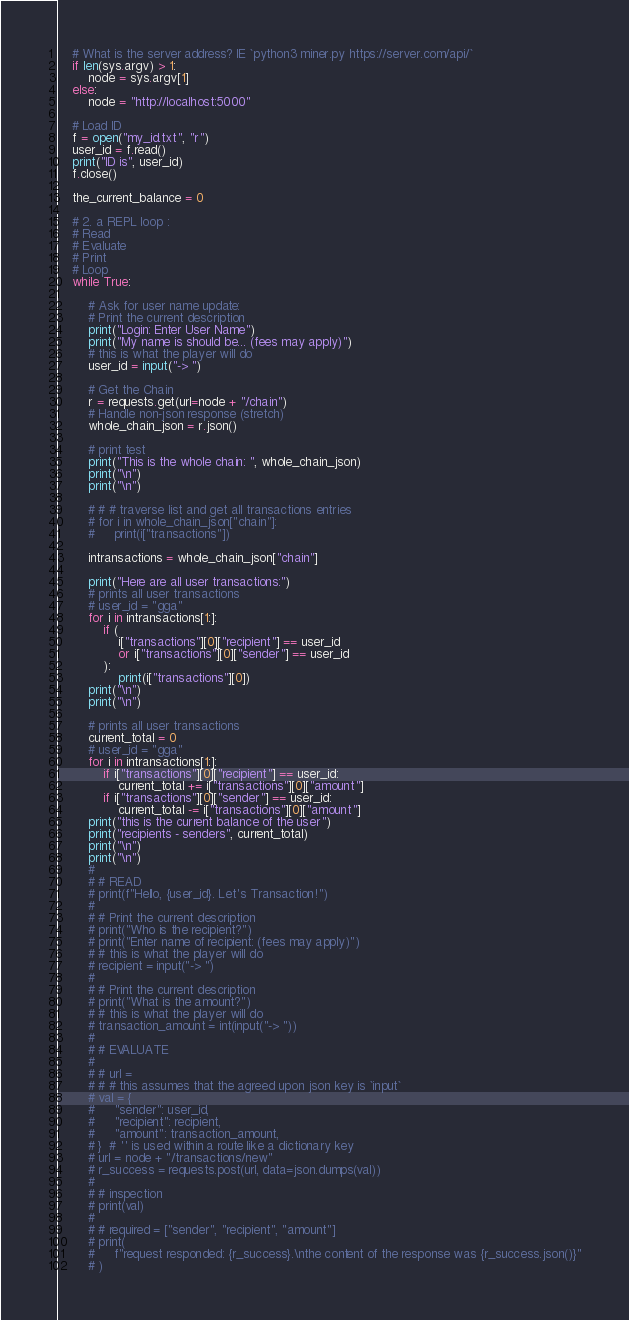<code> <loc_0><loc_0><loc_500><loc_500><_Python_>    # What is the server address? IE `python3 miner.py https://server.com/api/`
    if len(sys.argv) > 1:
        node = sys.argv[1]
    else:
        node = "http://localhost:5000"

    # Load ID
    f = open("my_id.txt", "r")
    user_id = f.read()
    print("ID is", user_id)
    f.close()

    the_current_balance = 0

    # 2. a REPL loop :
    # Read
    # Evaluate
    # Print
    # Loop
    while True:

        # Ask for user name update:
        # Print the current description
        print("Login: Enter User Name")
        print("My name is should be... (fees may apply)")
        # this is what the player will do
        user_id = input("-> ")

        # Get the Chain
        r = requests.get(url=node + "/chain")
        # Handle non-json response (stretch)
        whole_chain_json = r.json()

        # print test
        print("This is the whole chain: ", whole_chain_json)
        print("\n")
        print("\n")

        # # # traverse list and get all transactions entries
        # for i in whole_chain_json["chain"]:
        #     print(i["transactions"])

        intransactions = whole_chain_json["chain"]

        print("Here are all user transactions:")
        # prints all user transactions
        # user_id = "gga"
        for i in intransactions[1:]:
            if (
                i["transactions"][0]["recipient"] == user_id
                or i["transactions"][0]["sender"] == user_id
            ):
                print(i["transactions"][0])
        print("\n")
        print("\n")

        # prints all user transactions
        current_total = 0
        # user_id = "gga"
        for i in intransactions[1:]:
            if i["transactions"][0]["recipient"] == user_id:
                current_total += i["transactions"][0]["amount"]
            if i["transactions"][0]["sender"] == user_id:
                current_total -= i["transactions"][0]["amount"]
        print("this is the current balance of the user")
        print("recipients - senders", current_total)
        print("\n")
        print("\n")
        #
        # # READ
        # print(f"Hello, {user_id}. Let's Transaction!")
        #
        # # Print the current description
        # print("Who is the recipient?")
        # print("Enter name of recipient: (fees may apply)")
        # # this is what the player will do
        # recipient = input("-> ")
        #
        # # Print the current description
        # print("What is the amount?")
        # # this is what the player will do
        # transaction_amount = int(input("-> "))
        #
        # # EVALUATE
        #
        # # url =
        # # # this assumes that the agreed upon json key is `input`
        # val = {
        #     "sender": user_id,
        #     "recipient": recipient,
        #     "amount": transaction_amount,
        # }  # '' is used within a route like a dictionary key
        # url = node + "/transactions/new"
        # r_success = requests.post(url, data=json.dumps(val))
        #
        # # inspection
        # print(val)
        #
        # # required = ["sender", "recipient", "amount"]
        # print(
        #     f"request responded: {r_success}.\nthe content of the response was {r_success.json()}"
        # )
</code> 